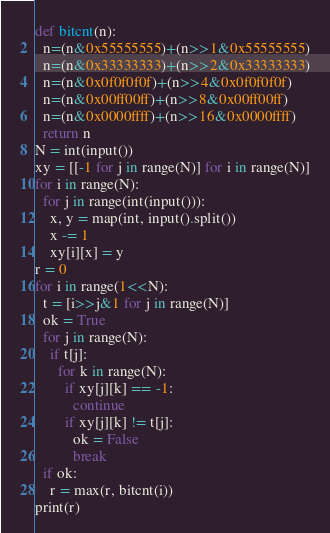<code> <loc_0><loc_0><loc_500><loc_500><_Python_>def bitcnt(n):
  n=(n&0x55555555)+(n>>1&0x55555555)
  n=(n&0x33333333)+(n>>2&0x33333333)
  n=(n&0x0f0f0f0f)+(n>>4&0x0f0f0f0f)
  n=(n&0x00ff00ff)+(n>>8&0x00ff00ff)
  n=(n&0x0000ffff)+(n>>16&0x0000ffff)
  return n
N = int(input())
xy = [[-1 for j in range(N)] for i in range(N)]
for i in range(N):
  for j in range(int(input())):
    x, y = map(int, input().split())
    x -= 1
    xy[i][x] = y
r = 0
for i in range(1<<N):
  t = [i>>j&1 for j in range(N)]
  ok = True
  for j in range(N):
    if t[j]:
      for k in range(N):
        if xy[j][k] == -1:
          continue
        if xy[j][k] != t[j]:
          ok = False
          break
  if ok:
    r = max(r, bitcnt(i))
print(r)</code> 